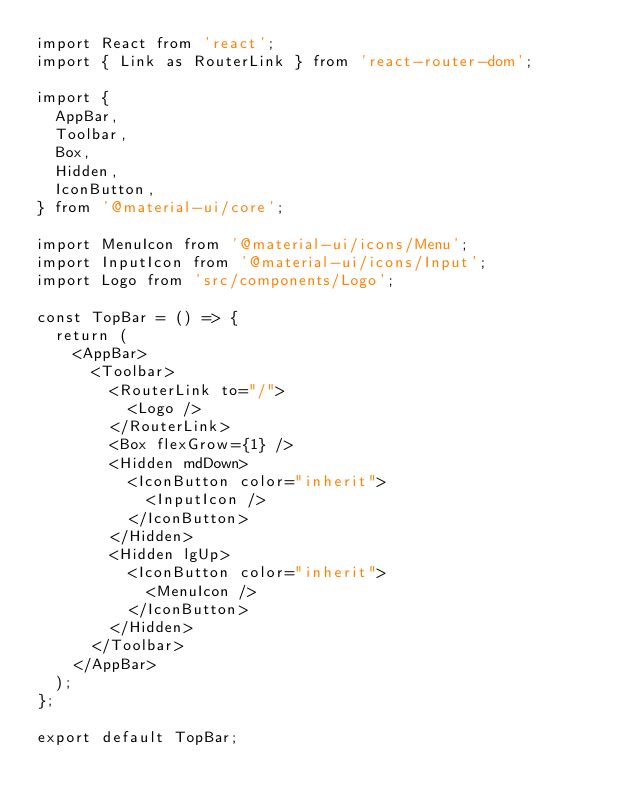<code> <loc_0><loc_0><loc_500><loc_500><_JavaScript_>import React from 'react';
import { Link as RouterLink } from 'react-router-dom';

import {
  AppBar,
  Toolbar,
  Box,
  Hidden,
  IconButton,
} from '@material-ui/core';

import MenuIcon from '@material-ui/icons/Menu';
import InputIcon from '@material-ui/icons/Input';
import Logo from 'src/components/Logo';

const TopBar = () => {
  return (
    <AppBar>
      <Toolbar>
        <RouterLink to="/">
          <Logo />
        </RouterLink>
        <Box flexGrow={1} />
        <Hidden mdDown>
          <IconButton color="inherit">
            <InputIcon />
          </IconButton>
        </Hidden>
        <Hidden lgUp>
          <IconButton color="inherit">
            <MenuIcon />
          </IconButton>
        </Hidden>
      </Toolbar>
    </AppBar>
  );
};

export default TopBar;
</code> 